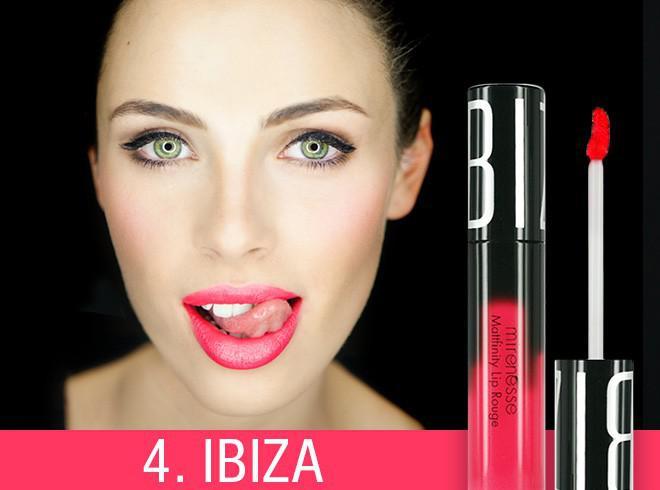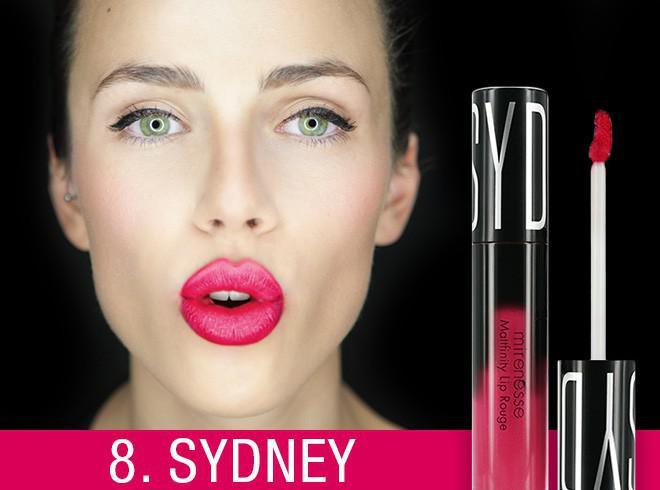The first image is the image on the left, the second image is the image on the right. Examine the images to the left and right. Is the description "One image shows lipstick on skin that is not lips." accurate? Answer yes or no. No. The first image is the image on the left, the second image is the image on the right. Examine the images to the left and right. Is the description "Right image shows a model's face on black next to a lipstick brush and tube." accurate? Answer yes or no. Yes. 